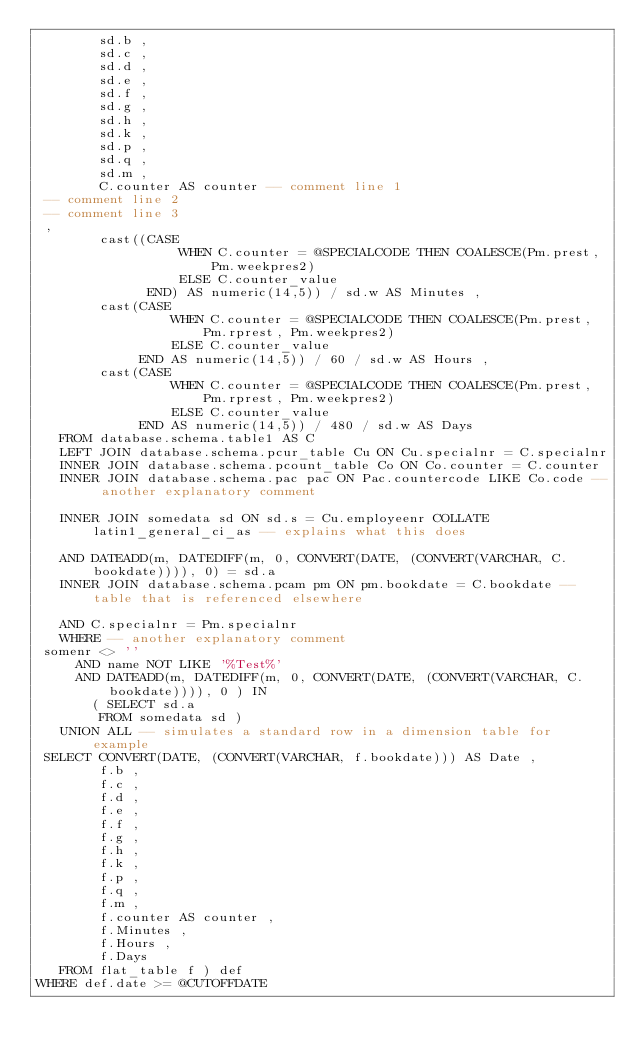<code> <loc_0><loc_0><loc_500><loc_500><_SQL_>        sd.b ,
        sd.c ,
        sd.d ,
        sd.e ,
        sd.f ,
        sd.g ,
        sd.h ,
        sd.k ,
        sd.p ,
        sd.q ,
        sd.m ,
        C.counter AS counter -- comment line 1
 -- comment line 2
 -- comment line 3
 ,
        cast((CASE
                  WHEN C.counter = @SPECIALCODE THEN COALESCE(Pm.prest, Pm.weekpres2)
                  ELSE C.counter_value
              END) AS numeric(14,5)) / sd.w AS Minutes ,
        cast(CASE
                 WHEN C.counter = @SPECIALCODE THEN COALESCE(Pm.prest, Pm.rprest, Pm.weekpres2)
                 ELSE C.counter_value
             END AS numeric(14,5)) / 60 / sd.w AS Hours ,
        cast(CASE
                 WHEN C.counter = @SPECIALCODE THEN COALESCE(Pm.prest, Pm.rprest, Pm.weekpres2)
                 ELSE C.counter_value
             END AS numeric(14,5)) / 480 / sd.w AS Days
   FROM database.schema.table1 AS C
   LEFT JOIN database.schema.pcur_table Cu ON Cu.specialnr = C.specialnr
   INNER JOIN database.schema.pcount_table Co ON Co.counter = C.counter
   INNER JOIN database.schema.pac pac ON Pac.countercode LIKE Co.code -- another explanatory comment

   INNER JOIN somedata sd ON sd.s = Cu.employeenr COLLATE latin1_general_ci_as -- explains what this does

   AND DATEADD(m, DATEDIFF(m, 0, CONVERT(DATE, (CONVERT(VARCHAR, C.bookdate)))), 0) = sd.a
   INNER JOIN database.schema.pcam pm ON pm.bookdate = C.bookdate -- table that is referenced elsewhere

   AND C.specialnr = Pm.specialnr
   WHERE -- another explanatory comment
 somenr <> ''
     AND name NOT LIKE '%Test%'
     AND DATEADD(m, DATEDIFF(m, 0, CONVERT(DATE, (CONVERT(VARCHAR, C.bookdate)))), 0 ) IN
       ( SELECT sd.a
        FROM somedata sd )
   UNION ALL -- simulates a standard row in a dimension table for example
 SELECT CONVERT(DATE, (CONVERT(VARCHAR, f.bookdate))) AS Date ,
        f.b ,
        f.c ,
        f.d ,
        f.e ,
        f.f ,
        f.g ,
        f.h ,
        f.k ,
        f.p ,
        f.q ,
        f.m ,
        f.counter AS counter ,
        f.Minutes ,
        f.Hours ,
        f.Days
   FROM flat_table f ) def
WHERE def.date >= @CUTOFFDATE
</code> 